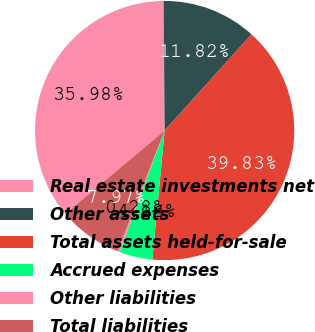Convert chart. <chart><loc_0><loc_0><loc_500><loc_500><pie_chart><fcel>Real estate investments net<fcel>Other assets<fcel>Total assets held-for-sale<fcel>Accrued expenses<fcel>Other liabilities<fcel>Total liabilities<nl><fcel>35.98%<fcel>11.82%<fcel>39.83%<fcel>4.12%<fcel>0.28%<fcel>7.97%<nl></chart> 